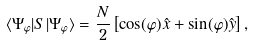<formula> <loc_0><loc_0><loc_500><loc_500>\langle \Psi _ { \varphi } | { S } | \Psi _ { \varphi } \rangle = \frac { N } { 2 } \left [ \cos ( \varphi ) { \hat { x } } + \sin ( \varphi ) { \hat { y } } \right ] ,</formula> 